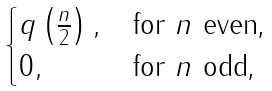Convert formula to latex. <formula><loc_0><loc_0><loc_500><loc_500>\begin{cases} q \left ( \frac { n } { 2 } \right ) , & \text {for $n$ even,} \\ 0 , & \text {for $n$ odd,} \end{cases}</formula> 